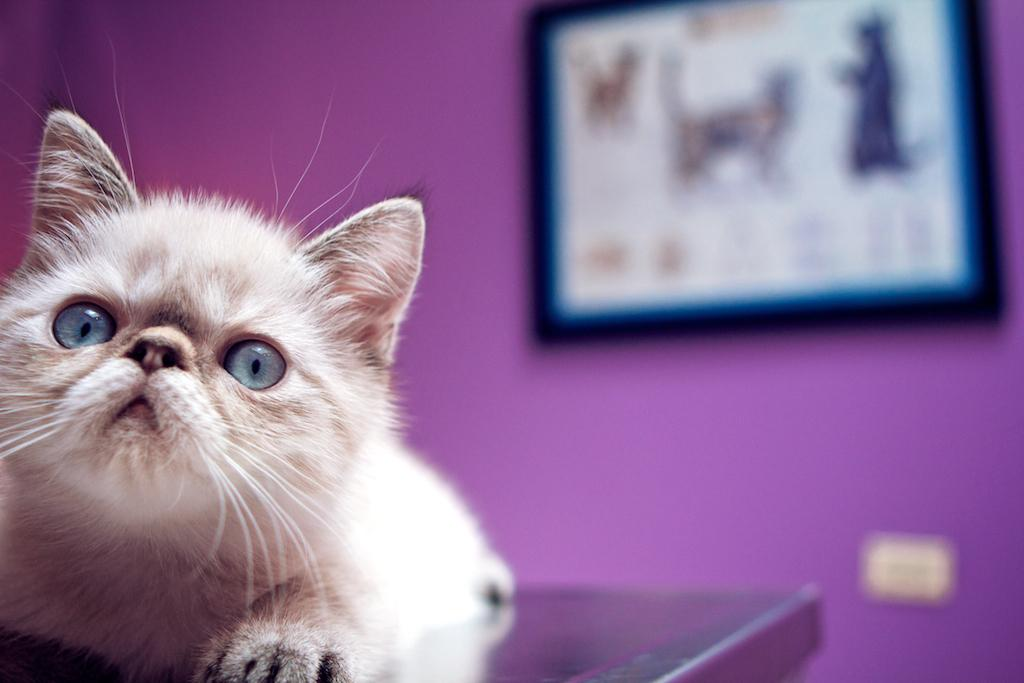What type of animal is in the image? There is a cat in the image. What can be seen in the background of the image? There is a wall in the background of the image. What object is present in the image that might hold a picture? There is a photo frame in the image. What type of bread is the cat eating in the image? There is no bread present in the image; the cat is not eating anything. 